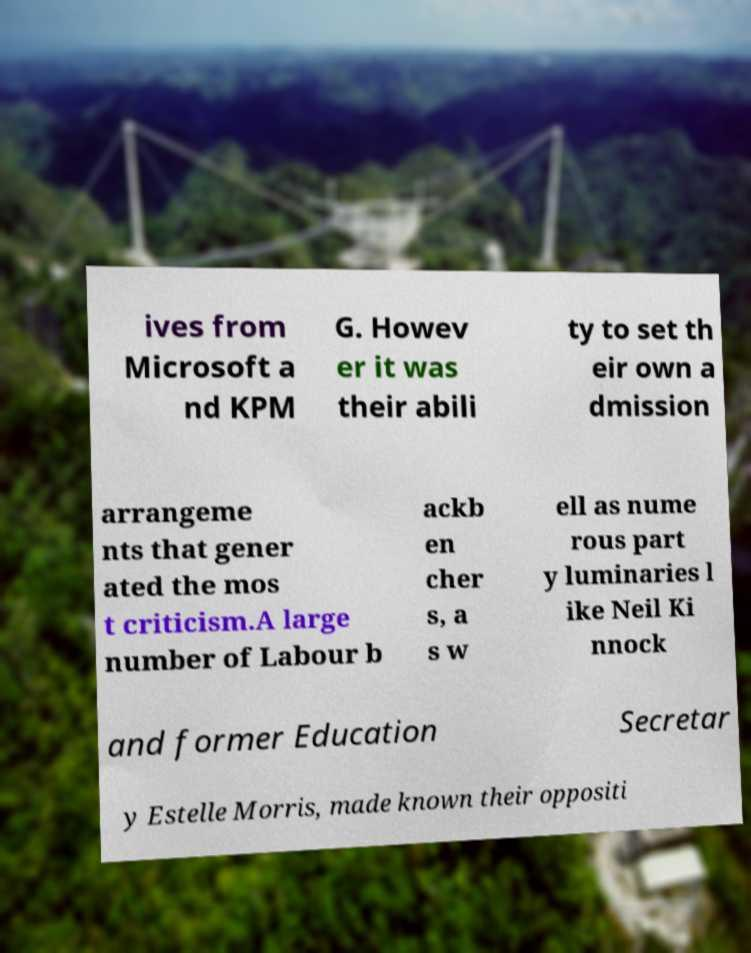What messages or text are displayed in this image? I need them in a readable, typed format. ives from Microsoft a nd KPM G. Howev er it was their abili ty to set th eir own a dmission arrangeme nts that gener ated the mos t criticism.A large number of Labour b ackb en cher s, a s w ell as nume rous part y luminaries l ike Neil Ki nnock and former Education Secretar y Estelle Morris, made known their oppositi 